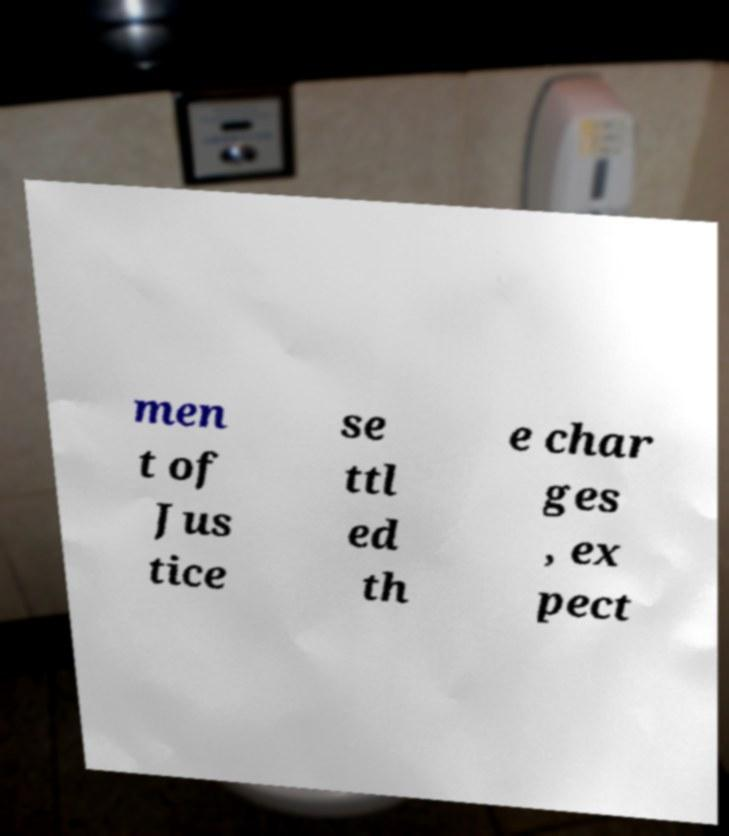For documentation purposes, I need the text within this image transcribed. Could you provide that? men t of Jus tice se ttl ed th e char ges , ex pect 